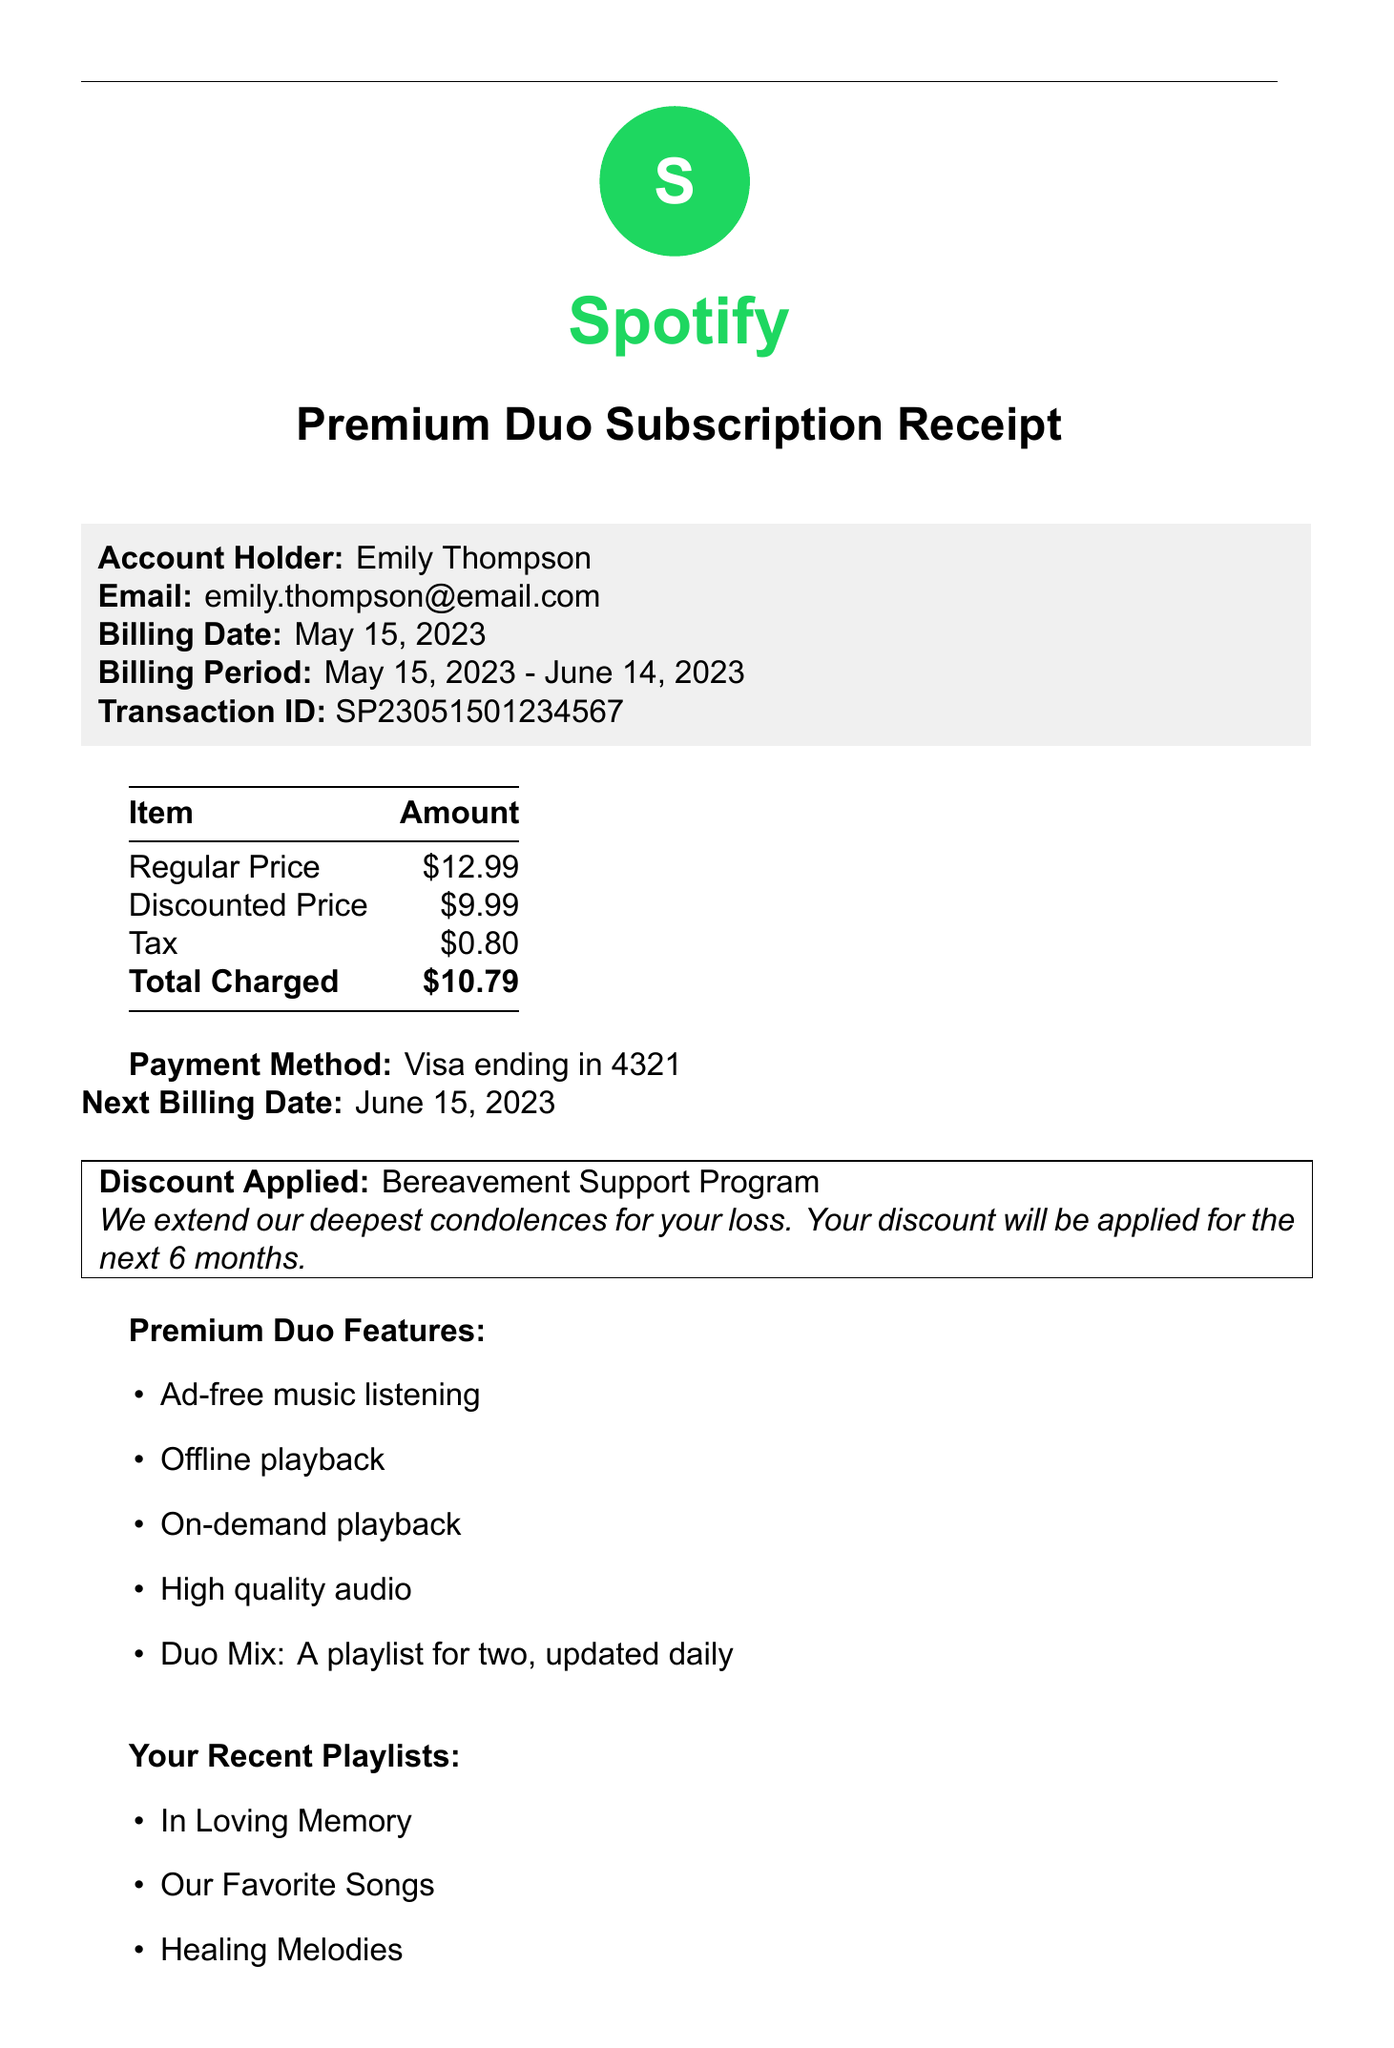What is the name of the streaming service? The streaming service listed in the document is specified at the beginning as Spotify.
Answer: Spotify What is the billing date? The billing date is mentioned clearly in the document as the date when the transaction occurred.
Answer: May 15, 2023 What is the discounted price for the subscription? The discounted price is noted in the financial section of the receipt, providing the lower cost for the subscription.
Answer: $9.99 Who is the account holder? The account holder's name is stated prominently on the receipt, denoting who is subscribed to the service.
Answer: Emily Thompson What is the reason for the discount? The reason for the discount is mentioned in the section discussing the financial details of the subscription.
Answer: Bereavement Support Program What is the total charged amount? The total charged amount is indicated in the financial section, which provides a summary of all charges.
Answer: $10.79 How long will the discount be applied? The document specifies a duration related to the discount being offered, indicating its time frame.
Answer: 6 months What payment method was used? The payment method is described in a straightforward manner, showing how the account was billed.
Answer: Visa ending in 4321 What are the recent playlists listed? The recent playlists are provided in a list format, showing the user's engagement with the service.
Answer: In Loving Memory, Our Favorite Songs, Healing Melodies 